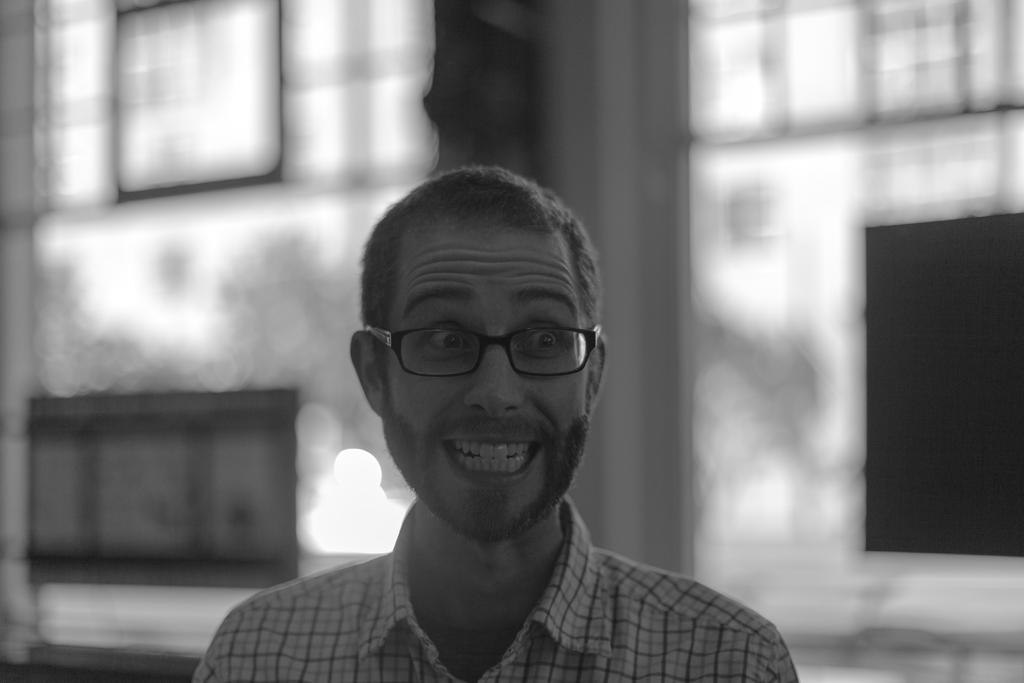Who is present in the image? There is a man in the image. What accessory is the man wearing? The man is wearing spectacles. Can you describe the background of the image? The background of the image is blurry. What type of stamp can be seen on the man's forehead in the image? There is no stamp present on the man's forehead in the image. 